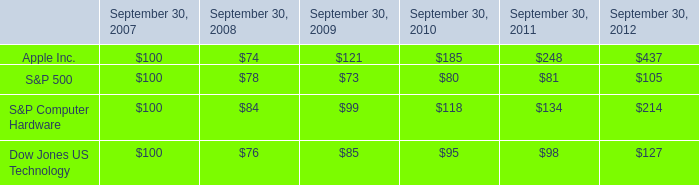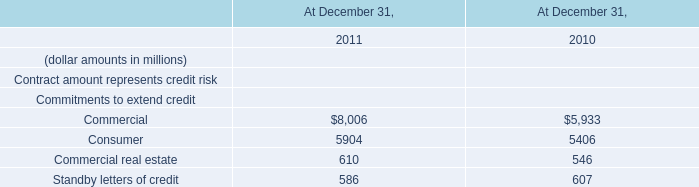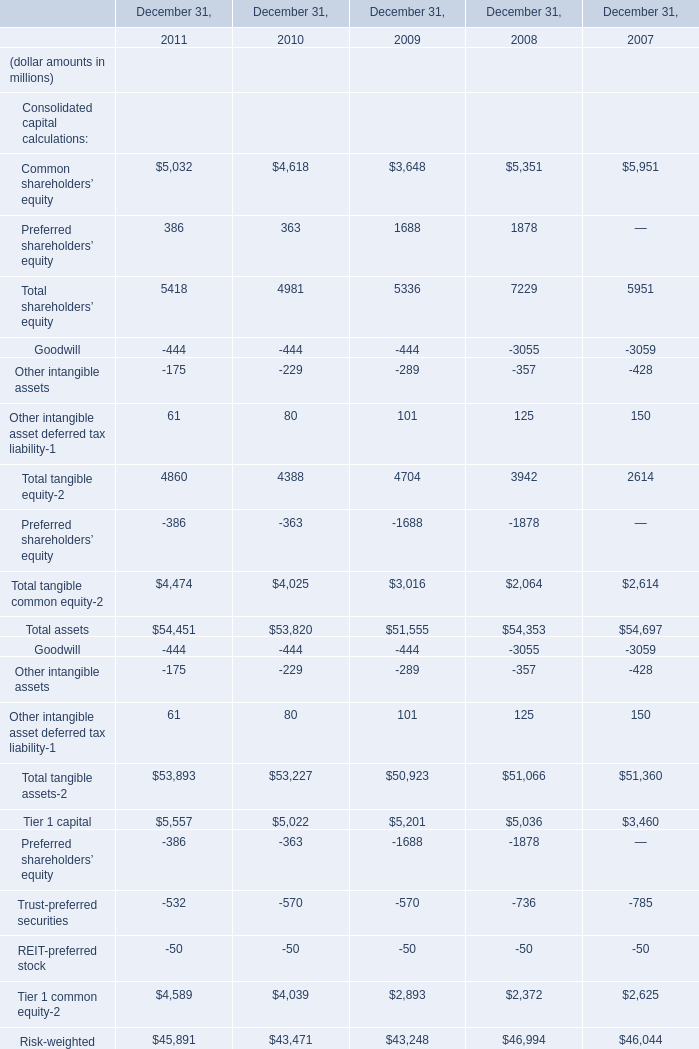What was the average value of Common shareholders’ equity, Preferred shareholders’ equity, goodwill in 2009? (in million) 
Computations: (((3648 + 1688) - 444) / 3)
Answer: 1630.66667. 